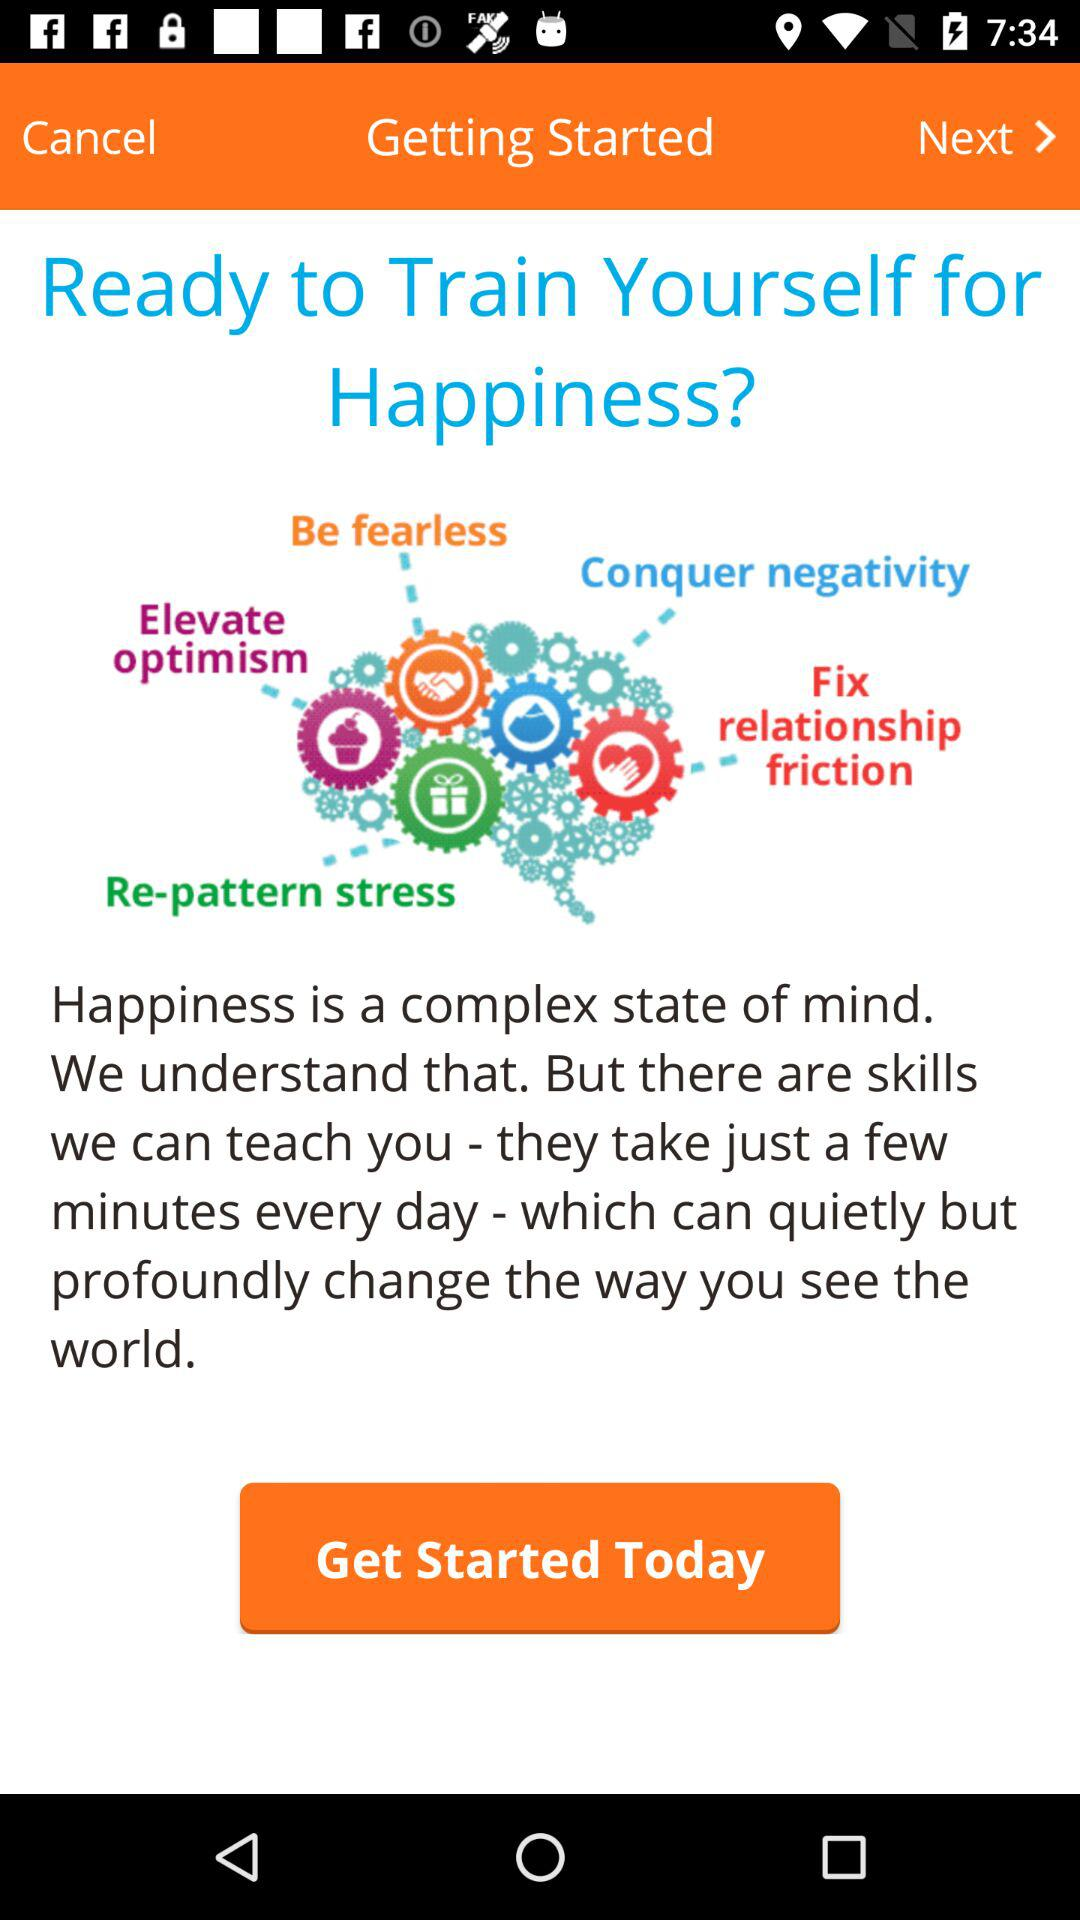What is the title of the topic? The title is "Ready to Train Yourself for Happiness?". 